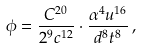<formula> <loc_0><loc_0><loc_500><loc_500>\phi = \frac { C ^ { 2 0 } } { 2 ^ { 9 } c ^ { 1 2 } } \cdot \frac { \alpha ^ { 4 } u ^ { 1 6 } } { d ^ { 8 } t ^ { 8 } } \, ,</formula> 